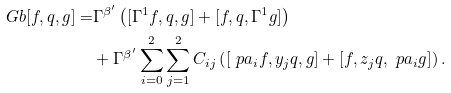Convert formula to latex. <formula><loc_0><loc_0><loc_500><loc_500>\ G b [ f , q , g ] = & \Gamma ^ { \beta ^ { \prime } } \left ( [ \Gamma ^ { 1 } f , q , g ] + [ f , q , \Gamma ^ { 1 } g ] \right ) \\ & + \Gamma ^ { \beta ^ { \prime } } \sum _ { i = 0 } ^ { 2 } \sum _ { j = 1 } ^ { 2 } C _ { i j } \left ( [ \ p a _ { i } f , y _ { j } q , g ] + [ f , z _ { j } q , \ p a _ { i } g ] \right ) .</formula> 